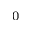Convert formula to latex. <formula><loc_0><loc_0><loc_500><loc_500>_ { 0 }</formula> 